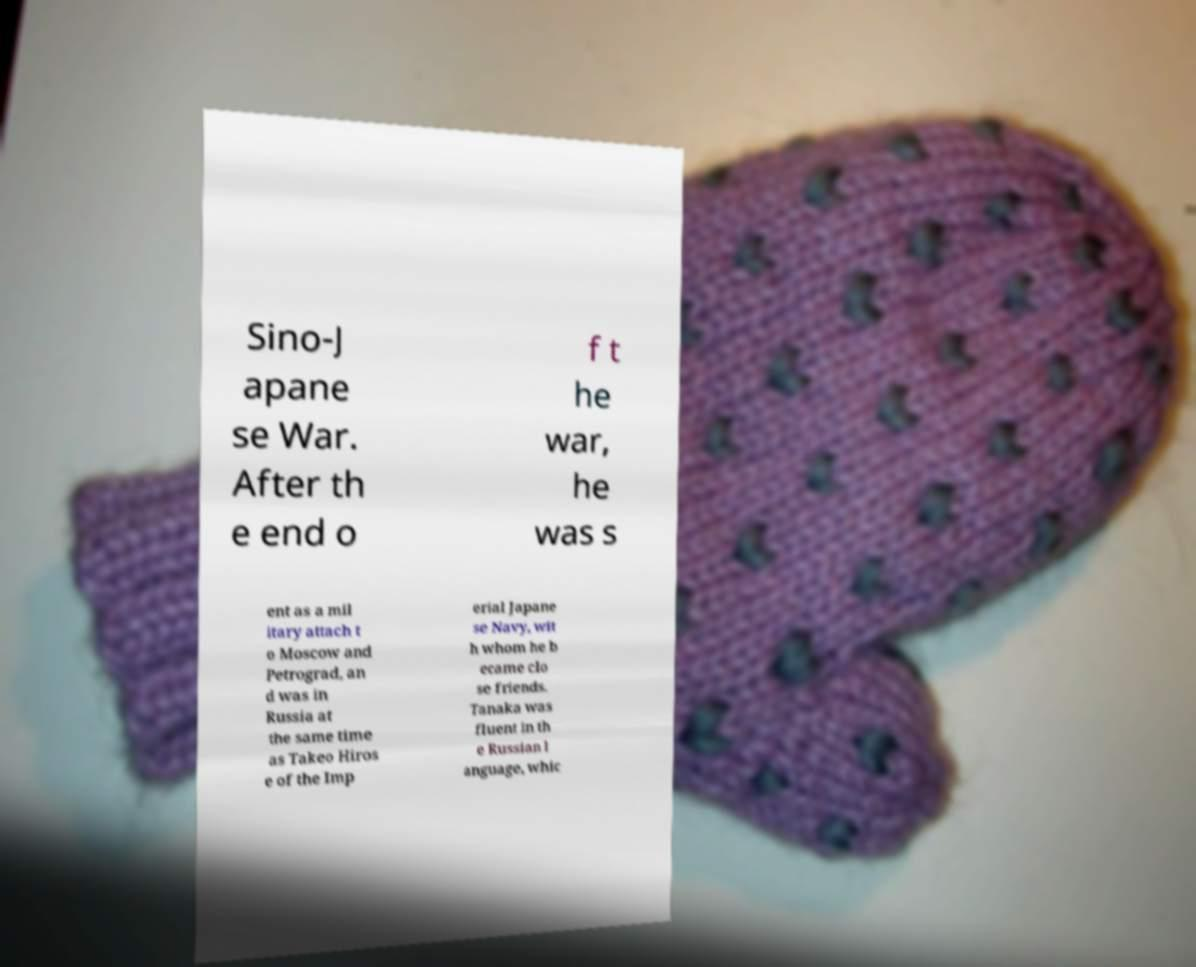Please read and relay the text visible in this image. What does it say? Sino-J apane se War. After th e end o f t he war, he was s ent as a mil itary attach t o Moscow and Petrograd, an d was in Russia at the same time as Takeo Hiros e of the Imp erial Japane se Navy, wit h whom he b ecame clo se friends. Tanaka was fluent in th e Russian l anguage, whic 